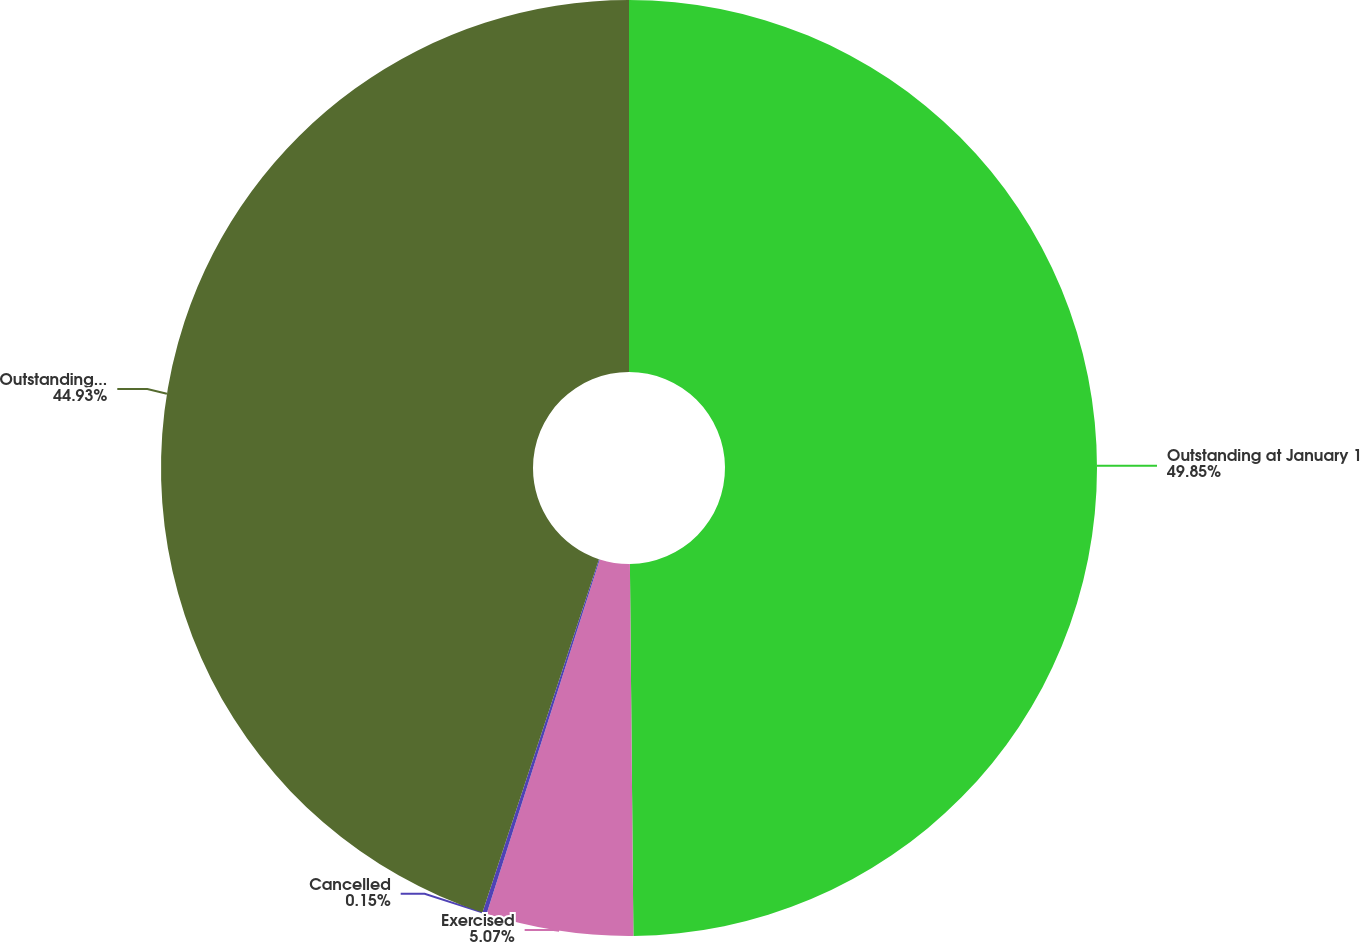Convert chart to OTSL. <chart><loc_0><loc_0><loc_500><loc_500><pie_chart><fcel>Outstanding at January 1<fcel>Exercised<fcel>Cancelled<fcel>Outstanding at December 31<nl><fcel>49.85%<fcel>5.07%<fcel>0.15%<fcel>44.93%<nl></chart> 